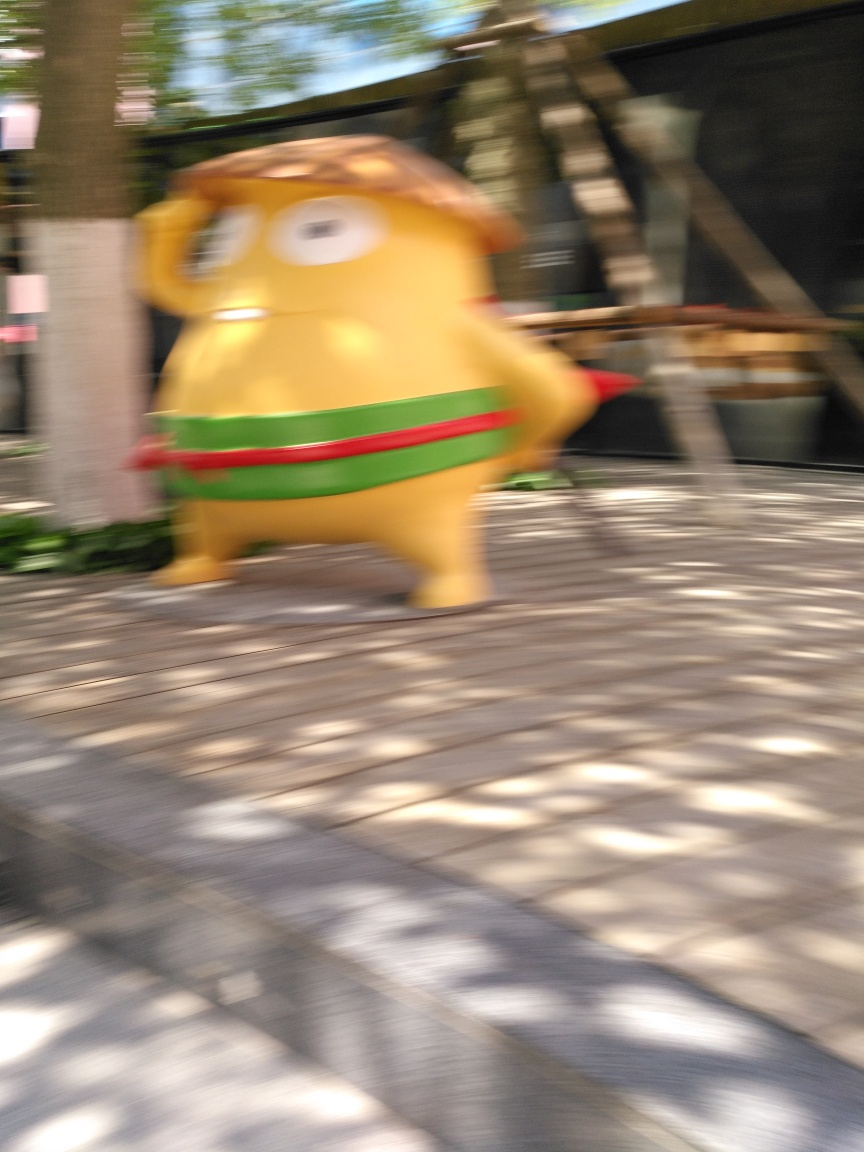What is the character in the image doing? Due to the motion blur it’s not possible to determine the exact action, but the character seems to be in motion, possibly walking or running, given the dynamic posture and blurred surroundings. What time of day does it appear to be in the image? The strong shadows on the ground suggest it's either midday or early afternoon, when the sun is high in the sky and produces the most direct downcast light. 